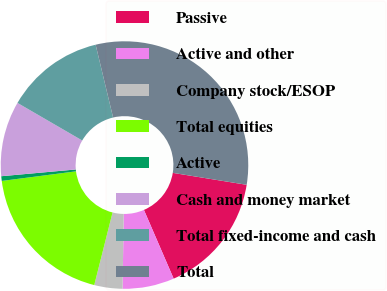<chart> <loc_0><loc_0><loc_500><loc_500><pie_chart><fcel>Passive<fcel>Active and other<fcel>Company stock/ESOP<fcel>Total equities<fcel>Active<fcel>Cash and money market<fcel>Total fixed-income and cash<fcel>Total<nl><fcel>15.95%<fcel>6.75%<fcel>3.68%<fcel>19.02%<fcel>0.61%<fcel>9.81%<fcel>12.88%<fcel>31.3%<nl></chart> 